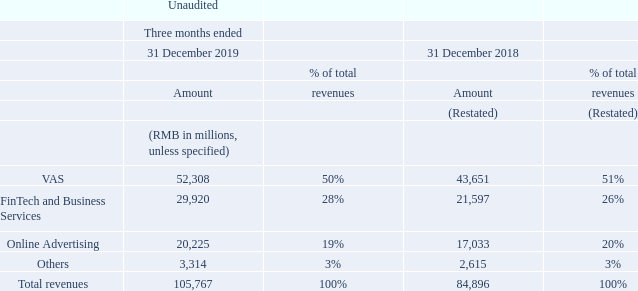Revenues. Revenues increased by 25% to RMB105.8 billion for the fourth quarter of 2019 on a year-on-year basis. The following table sets forth our revenues by line of business for the fourth quarter of 2019 and the fourth quarter of 2018:
Revenues from VAS increased by 20% to RMB52,308 million for the fourth quarter of 2019 on a year-on-year basis. Online games revenues grew by 25% to RMB30,286 million. The increase was primarily driven by revenue growth from smart phone games in both domestic and overseas markets, including titles such as Peacekeeper Elite and PUBG Mobile, as well as revenue contributions from Supercell titles, partly offset by lower revenues from PC client games such as DnF. Social networks revenues increased by 13% to RMB22,022 million. The increase mainly reflected greater contributions from digital content services such as live broadcast and music streaming services. Total smart phone games revenues (including smart phone games revenues attributable to our social networks business) were RMB26,035 million and PC client games revenues were RMB10,359 million for the fourth quarter of 2019.
Revenues from FinTech and Business Services increased by 39% to RMB29,920 million for the fourth quarter of 2019 on a year-on-year basis. The increase was primarily due to greater revenue contributions from commercial payment, as well as revenue growth from cloud services as a result of deeper penetration in key verticals.
Revenues from Online Advertising increased by 19% to RMB20,225 million for the fourth quarter of 2019 on a year-onyear basis. Social and others advertising revenues increased by 37% to RMB16,274 million. The increase was mainly driven by advertising revenue growth from Weixin Moments and our mobile advertising network. Media advertising revenues decreased by 24% to RMB3,951 million. The decrease primarily reflected lower advertising revenues from our media platforms including Tencent Video and Tencent News due to uncertain broadcasting schedules and fewer telecasts of sports events.
What was the increase in revenues for the fourth quarter of 2019 on a year-on-year basis? 25%. What was the primary reason for the increase in VAS revenue between the fourth quarter of 2018 and 2019? The increase was primarily driven by revenue growth from smart phone games in both domestic and overseas markets, including titles such as peacekeeper elite and pubg mobile, as well as revenue contributions from supercell titles, partly offset by lower revenues from pc client games such as dnf. What was the primary reason for the increase in FinTech and Business Services revenue between the fourth quarter of 2018 and 2019? The increase was primarily due to greater revenue contributions from commercial payment, as well as revenue growth from cloud services as a result of deeper penetration in key verticals. How much is the change in VAS revenue between the fourth quarter of 2018 and 2019?
Answer scale should be: million. 52,308-43,651
Answer: 8657. How much is the change in FinTech and Business Services revenue between the fourth quarter of 2018 and 2019?
Answer scale should be: million. 29,920-21,597
Answer: 8323. How much is the change in Online Advertising revenue between the fourth quarter of 2018 and 2019?
Answer scale should be: million. 20,225-17,033
Answer: 3192. 